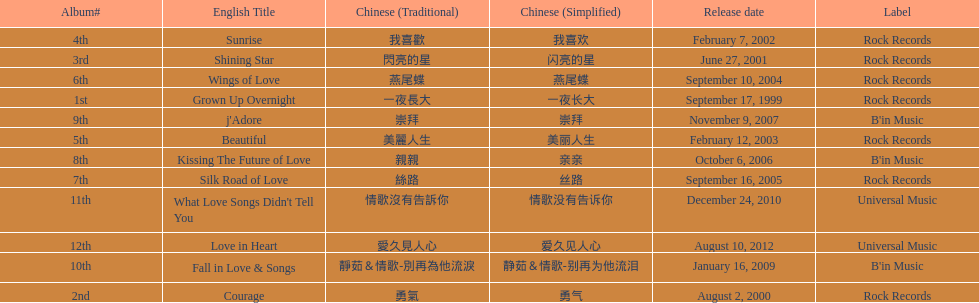What is the name of her last album produced with rock records? Silk Road of Love. 